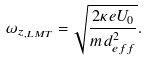<formula> <loc_0><loc_0><loc_500><loc_500>\omega _ { z _ { , L M T } } = \sqrt { \frac { { 2 \kappa e U _ { 0 } } } { { m d _ { e f f } ^ { 2 } } } } .</formula> 